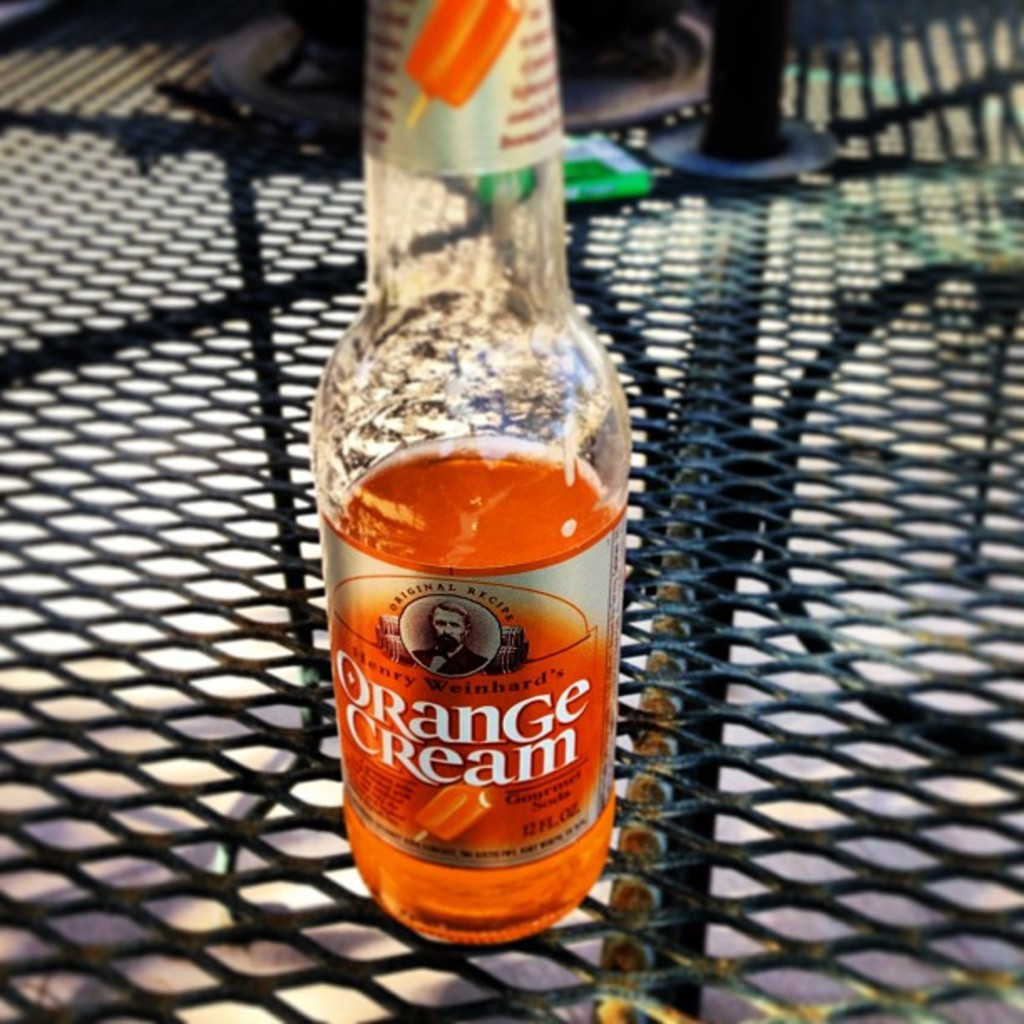How would you describe the ambiance where this bottle is placed? The bottle is set upon a metal mesh table, bathed in sunlight suggesting a relaxed, outdoor setting, perhaps a casual afternoon break. 